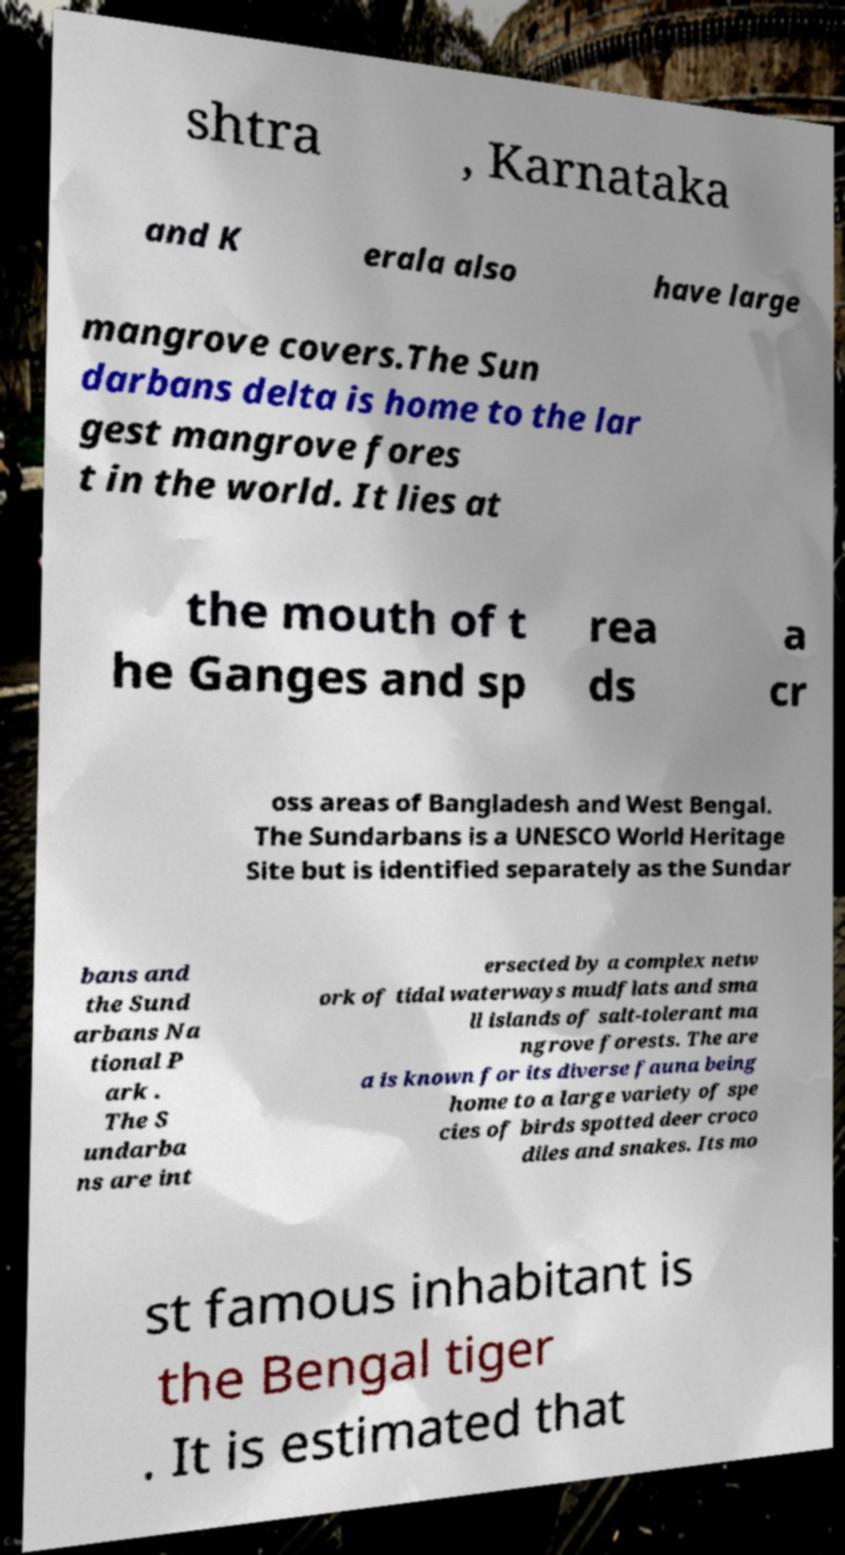Can you accurately transcribe the text from the provided image for me? shtra , Karnataka and K erala also have large mangrove covers.The Sun darbans delta is home to the lar gest mangrove fores t in the world. It lies at the mouth of t he Ganges and sp rea ds a cr oss areas of Bangladesh and West Bengal. The Sundarbans is a UNESCO World Heritage Site but is identified separately as the Sundar bans and the Sund arbans Na tional P ark . The S undarba ns are int ersected by a complex netw ork of tidal waterways mudflats and sma ll islands of salt-tolerant ma ngrove forests. The are a is known for its diverse fauna being home to a large variety of spe cies of birds spotted deer croco diles and snakes. Its mo st famous inhabitant is the Bengal tiger . It is estimated that 